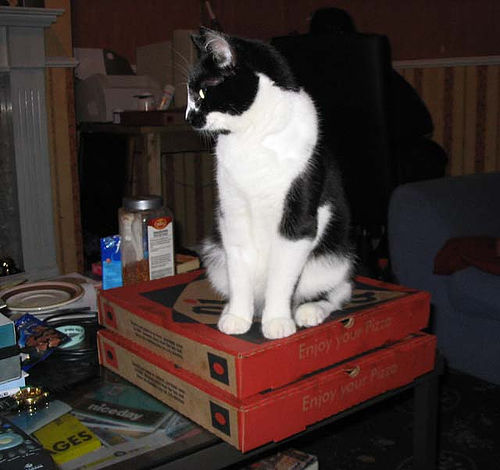<image>Whose pets are these? It is unknown whose pets are these. Whose pets are these? It is ambiguous whose pets these are. They can belong to the owner, homeowner, person or woman. 